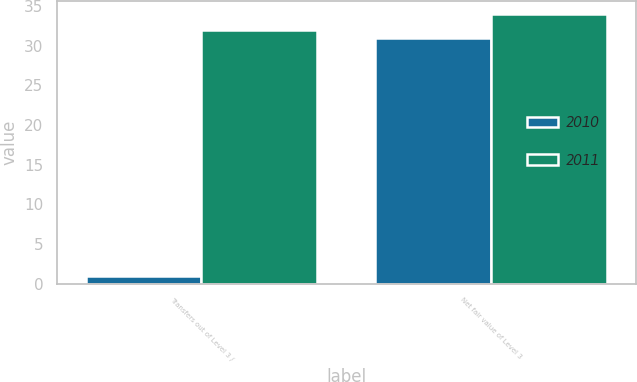Convert chart to OTSL. <chart><loc_0><loc_0><loc_500><loc_500><stacked_bar_chart><ecel><fcel>Transfers out of Level 3 /<fcel>Net fair value of Level 3<nl><fcel>2010<fcel>1<fcel>31<nl><fcel>2011<fcel>32<fcel>34<nl></chart> 